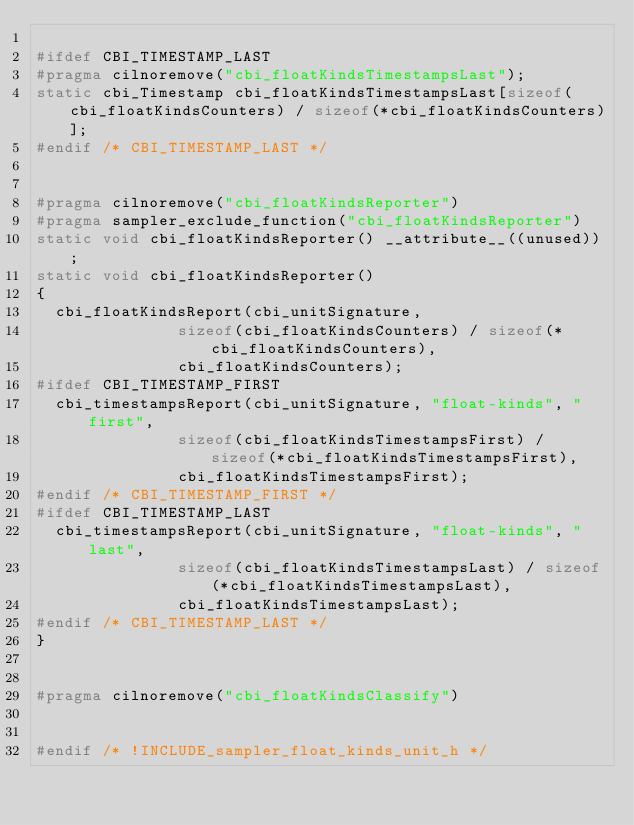Convert code to text. <code><loc_0><loc_0><loc_500><loc_500><_C_>
#ifdef CBI_TIMESTAMP_LAST
#pragma cilnoremove("cbi_floatKindsTimestampsLast");
static cbi_Timestamp cbi_floatKindsTimestampsLast[sizeof(cbi_floatKindsCounters) / sizeof(*cbi_floatKindsCounters)];
#endif /* CBI_TIMESTAMP_LAST */


#pragma cilnoremove("cbi_floatKindsReporter")
#pragma sampler_exclude_function("cbi_floatKindsReporter")
static void cbi_floatKindsReporter() __attribute__((unused));
static void cbi_floatKindsReporter()
{
  cbi_floatKindsReport(cbi_unitSignature,
		       sizeof(cbi_floatKindsCounters) / sizeof(*cbi_floatKindsCounters),
		       cbi_floatKindsCounters);
#ifdef CBI_TIMESTAMP_FIRST
  cbi_timestampsReport(cbi_unitSignature, "float-kinds", "first",
		       sizeof(cbi_floatKindsTimestampsFirst) / sizeof(*cbi_floatKindsTimestampsFirst),
		       cbi_floatKindsTimestampsFirst);
#endif /* CBI_TIMESTAMP_FIRST */
#ifdef CBI_TIMESTAMP_LAST
  cbi_timestampsReport(cbi_unitSignature, "float-kinds", "last",
		       sizeof(cbi_floatKindsTimestampsLast) / sizeof(*cbi_floatKindsTimestampsLast),
		       cbi_floatKindsTimestampsLast);
#endif /* CBI_TIMESTAMP_LAST */
}


#pragma cilnoremove("cbi_floatKindsClassify")


#endif /* !INCLUDE_sampler_float_kinds_unit_h */
</code> 